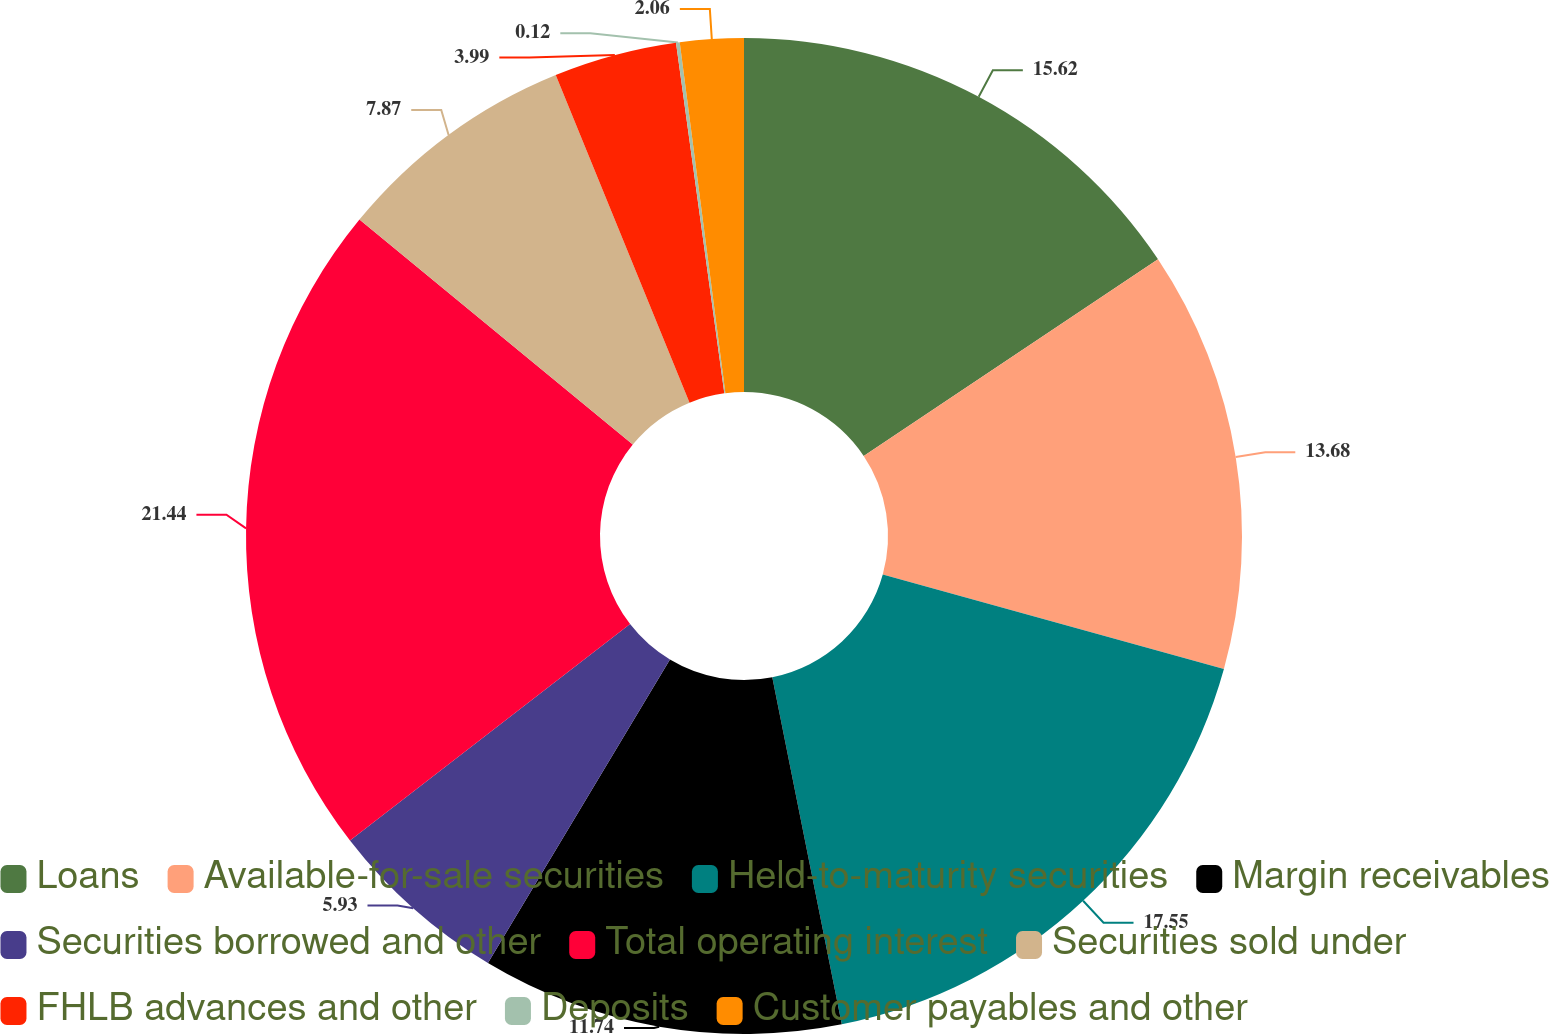Convert chart. <chart><loc_0><loc_0><loc_500><loc_500><pie_chart><fcel>Loans<fcel>Available-for-sale securities<fcel>Held-to-maturity securities<fcel>Margin receivables<fcel>Securities borrowed and other<fcel>Total operating interest<fcel>Securities sold under<fcel>FHLB advances and other<fcel>Deposits<fcel>Customer payables and other<nl><fcel>15.62%<fcel>13.68%<fcel>17.55%<fcel>11.74%<fcel>5.93%<fcel>21.43%<fcel>7.87%<fcel>3.99%<fcel>0.12%<fcel>2.06%<nl></chart> 